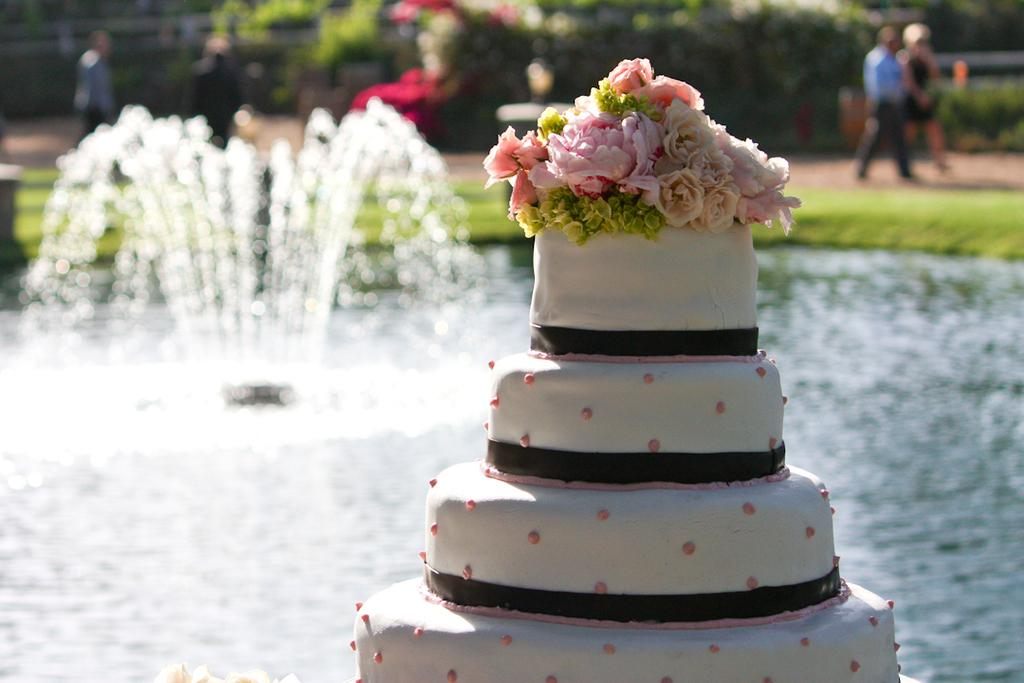What is the main subject in the foreground of the image? There is a cake in the foreground of the image. What else can be seen in the foreground of the image? There is water and a fountain in the foreground of the image. What type of natural environment is visible in the background of the image? There is grass, plants, and trees in the background of the image. What else can be seen in the background of the image? There is a group of people on the road in the background of the image. Can you make an educated guess about the location of the image? The image may have been taken in a park, given the presence of a fountain, grass, and trees. How many girls are tasting the cake in the image? There are no girls present in the image, nor is there any indication that anyone is tasting the cake. --- Facts: 1. There is a car in the image. 2. The car is red. 3. The car has four wheels. 4. The car has a license plate. 5. The car has a sunroof. 6. The car is parked on the side of the road. Absurd Topics: elephant, piano Conversation: What is the main subject in the image? There is a car in the image. What color is the car? The car is red. How many wheels does the car have? The car has four wheels. Does the car have a license plate? Yes, the car has a license plate. What additional feature does the car have? The car has a sunroof. Where is the car located in the image? The car is parked on the side of the road. Reasoning: Let's think step by step in order to produce the conversation. We start by identifying the main subject in the image, which is the car. Next, we describe specific features of the car, such as its color, the number of wheels it has, and the presence of a license plate. Then, we mention an additional feature of the car, which is the sunroof. Finally, we describe the location of the car in the image, which is parked on the side of the road. Absurd Question/Answer: Can you hear the elephant playing the piano in the image? There is no elephant or piano present in the image, so it is not possible to hear any music being played. 